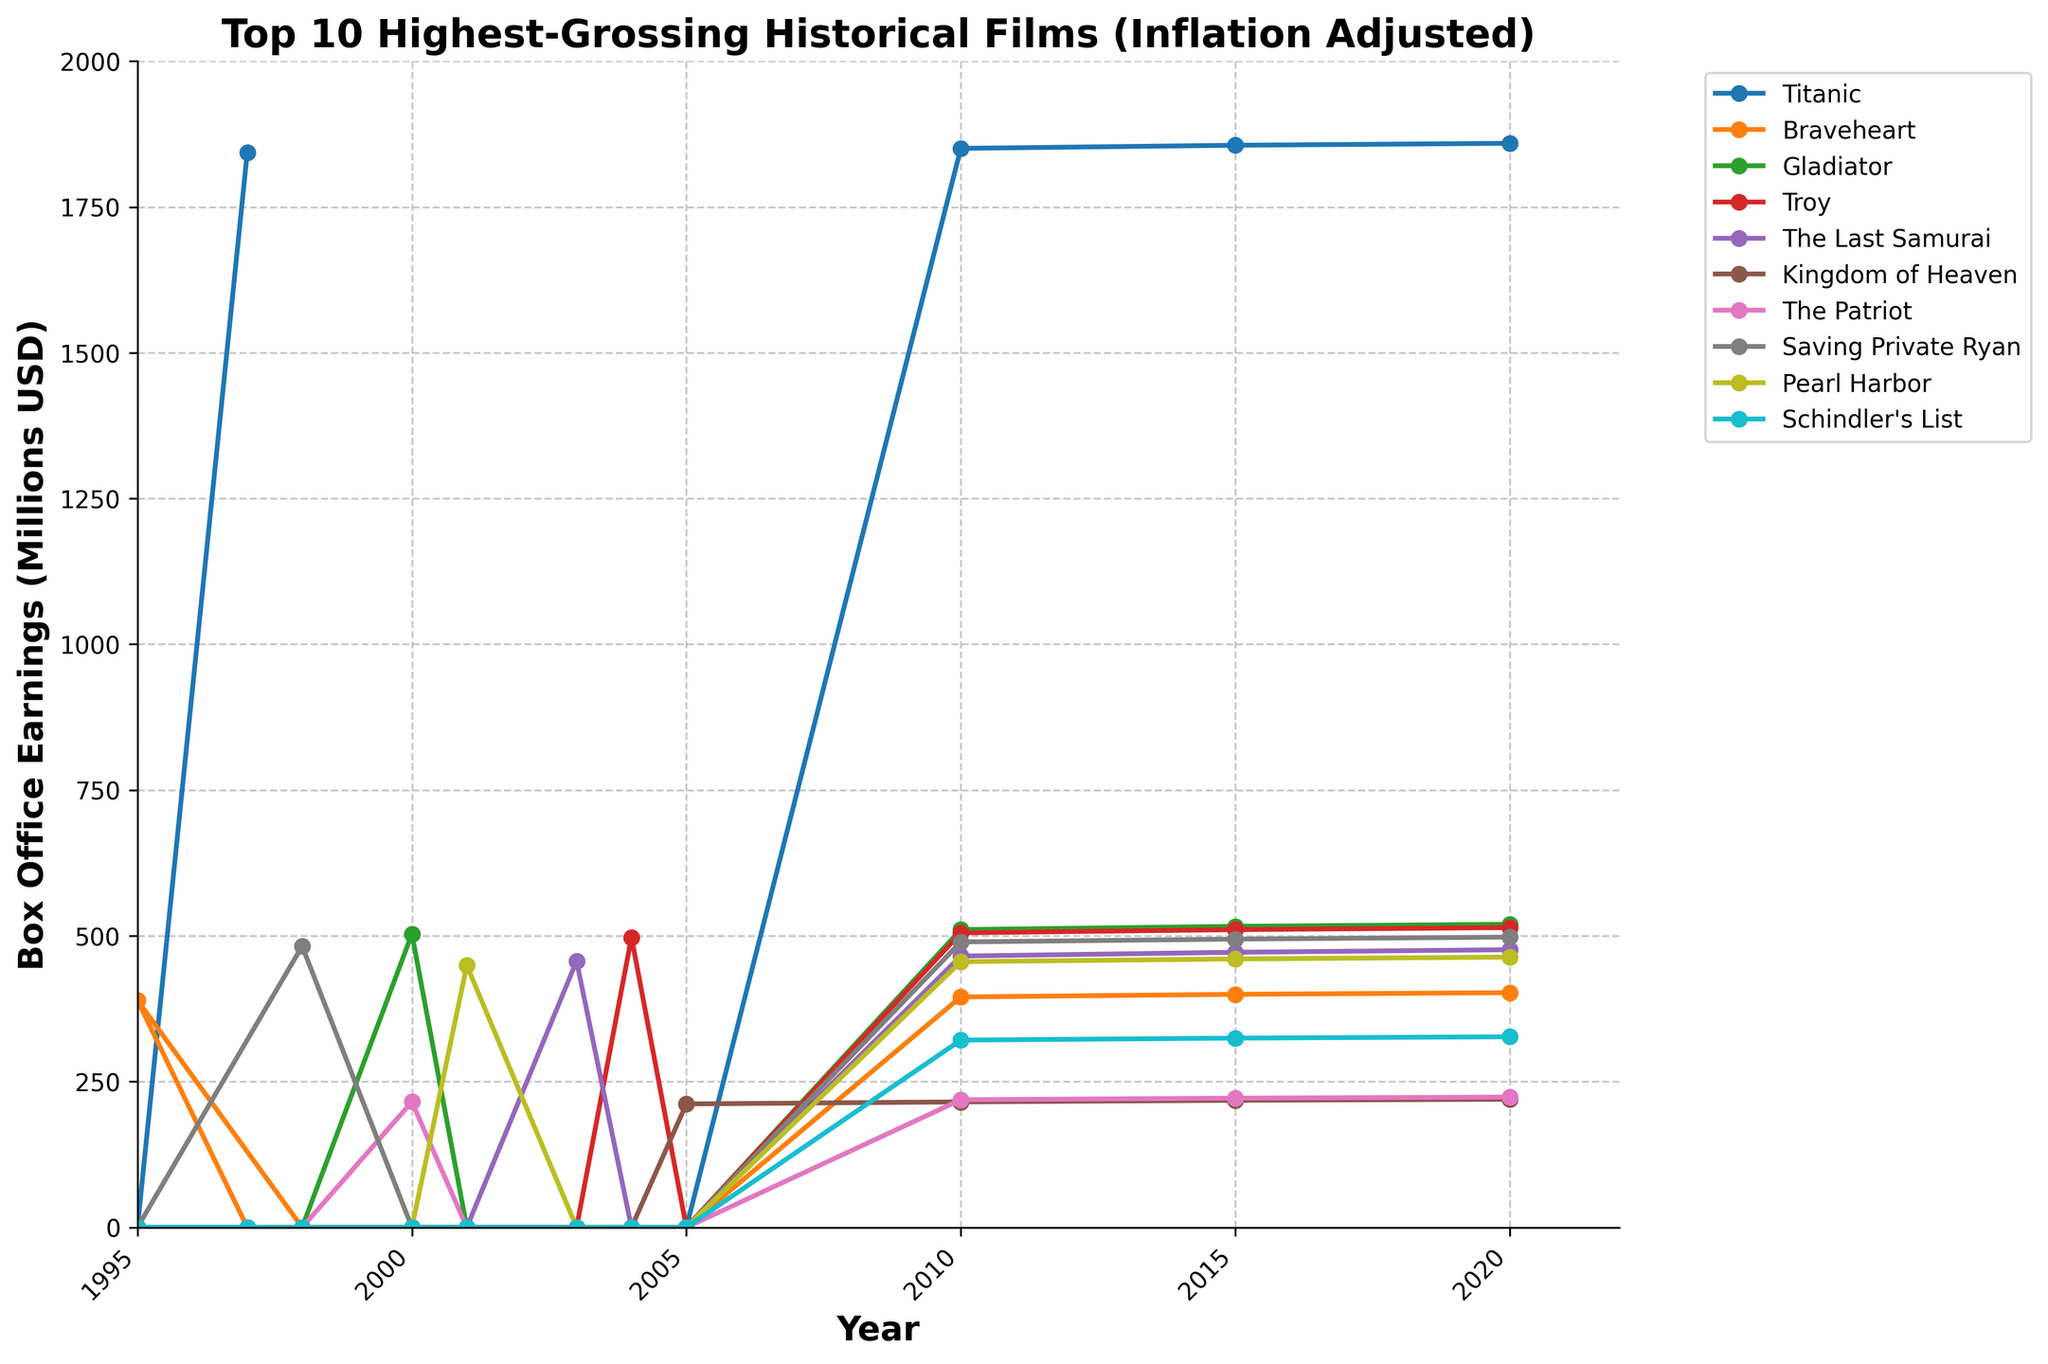Which movie had the highest box office earnings in 1997? Check the plot to see which movie has a data point in 1997. The highest earnings in that year were for "Titanic".
Answer: Titanic By how much did "Gladiator" increase its box office earnings from 2000 to 2015? Find the points for "Gladiator" in 2000 and 2015 and subtract them: 2015 value (516.3) - 2000 value (503.2).
Answer: 13.1 What is the average box office earnings for "Saving Private Ryan" over the years it is listed on the chart? Add the values for all available years: 482.3 (1998), 489.5 (2010), 494.4 (2015), 497.8 (2020) and divide by the number of years (4).
Answer: 491 Which movie has the steadiest increase in box office earnings from 2010 to 2020? Check the slopes of the lines between 2010 and 2020. "Titanic" shows a steady, almost linear increase over these years.
Answer: Titanic Did "Pearl Harbor" ever surpass "Schindler's List" in box office earnings? Compare their earnings by years they appear on the graph. "Pearl Harbor" (449.2 in 2001, 455.7 in 2010, 460.3 in 2015, 463.5 in 2020) is consistently higher than "Schindler's List" (321.2 in 2010, 324.6 in 2015, 326.9 in 2020).
Answer: Yes In which year did "The Last Samurai" achieve its highest earnings? Find the highest data point for "The Last Samurai" and its corresponding year. Its highest earnings are in 2020 with earnings of 476.2.
Answer: 2020 How much more did "Titanic" earn in 2020 compared to "Braveheart" in the same year? Subtract "Braveheart" earnings in 2020 (402.5) from "Titanic" earnings in 2020 (1859.2).
Answer: 1456.7 Which movie had no box office earnings in 1995? All movies except "Braveheart" had earnings of 0 in 1995.
Answer: Titanic, Gladiator, Troy, The Last Samurai, Kingdom of Heaven, The Patriot, Saving Private Ryan, Pearl Harbor, Schindler's List When did "Braveheart" first appear on the chart? "Braveheart" first shows earnings in 1995.
Answer: 1995 